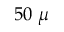Convert formula to latex. <formula><loc_0><loc_0><loc_500><loc_500>5 0 \mu</formula> 